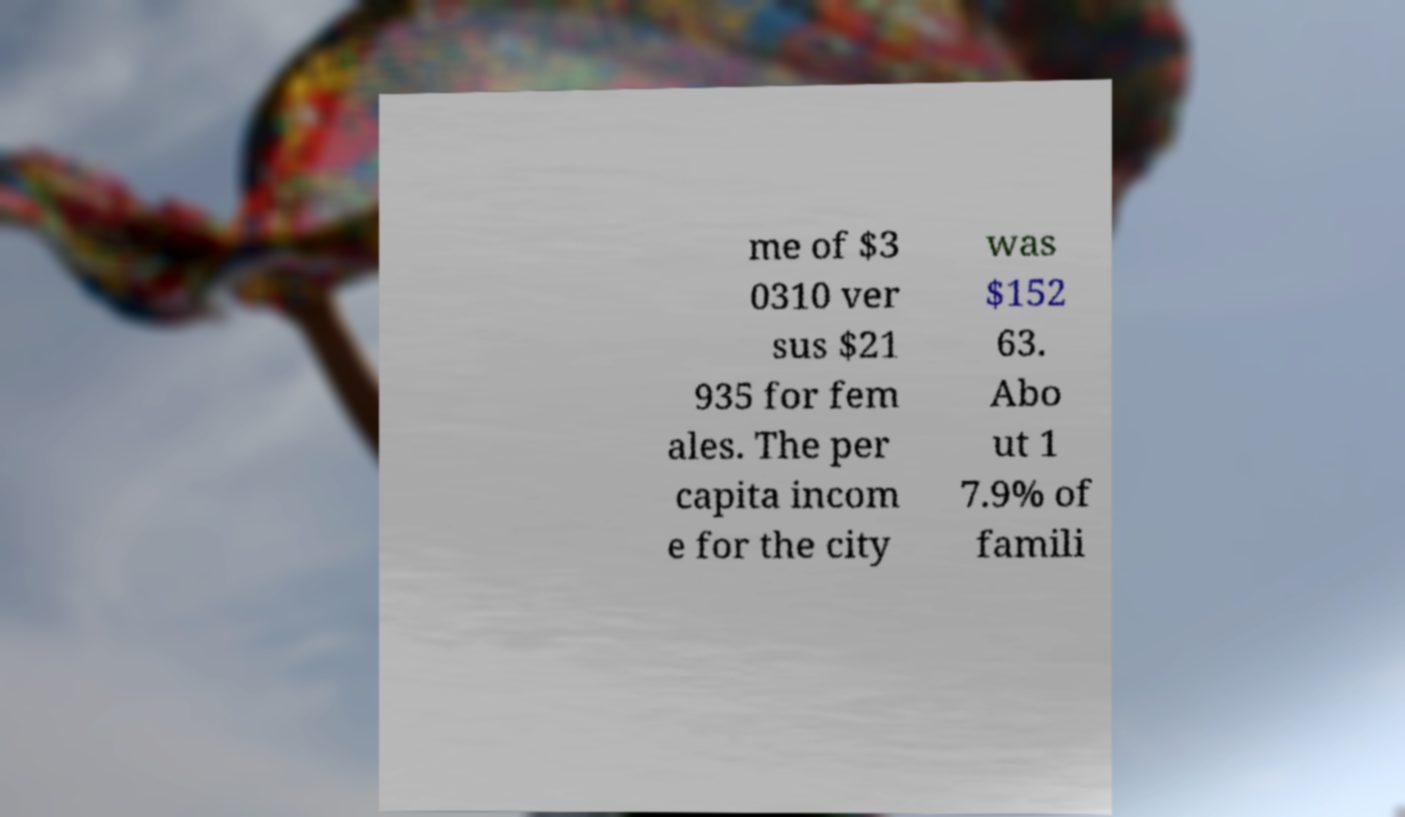Can you read and provide the text displayed in the image?This photo seems to have some interesting text. Can you extract and type it out for me? me of $3 0310 ver sus $21 935 for fem ales. The per capita incom e for the city was $152 63. Abo ut 1 7.9% of famili 